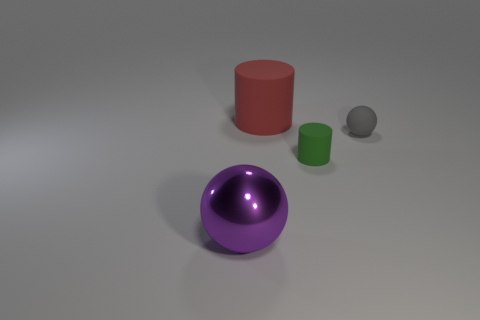What number of tiny red objects have the same shape as the purple metal thing?
Offer a terse response. 0. What number of large purple blocks are there?
Provide a succinct answer. 0. There is a tiny green thing; is its shape the same as the object behind the gray ball?
Provide a short and direct response. Yes. How many things are large red things or large objects behind the shiny ball?
Provide a short and direct response. 1. What is the material of the other small object that is the same shape as the red object?
Offer a terse response. Rubber. Does the tiny thing that is in front of the gray matte thing have the same shape as the red rubber object?
Make the answer very short. Yes. Is there anything else that is the same size as the purple metallic thing?
Offer a very short reply. Yes. Is the number of small rubber cylinders that are in front of the purple shiny ball less than the number of tiny rubber cylinders that are behind the tiny rubber cylinder?
Your answer should be very brief. No. What number of other things are the same shape as the purple metal thing?
Ensure brevity in your answer.  1. What size is the rubber cylinder behind the small object that is to the left of the gray ball that is in front of the large red matte thing?
Make the answer very short. Large. 